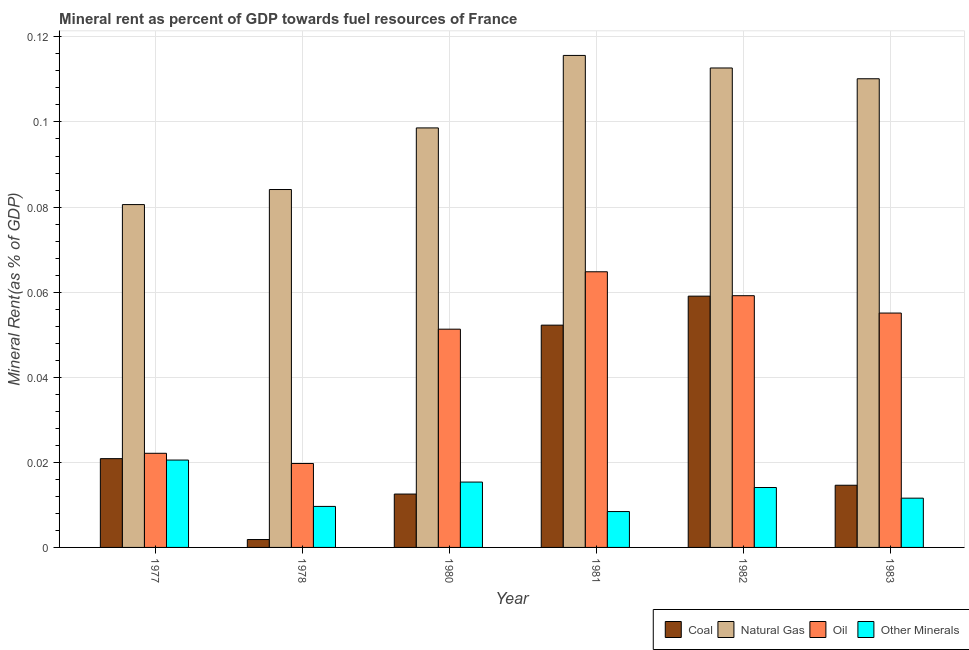How many different coloured bars are there?
Make the answer very short. 4. Are the number of bars per tick equal to the number of legend labels?
Ensure brevity in your answer.  Yes. How many bars are there on the 3rd tick from the left?
Your response must be concise. 4. How many bars are there on the 4th tick from the right?
Keep it short and to the point. 4. What is the label of the 5th group of bars from the left?
Your answer should be very brief. 1982. In how many cases, is the number of bars for a given year not equal to the number of legend labels?
Provide a short and direct response. 0. What is the coal rent in 1977?
Provide a succinct answer. 0.02. Across all years, what is the maximum natural gas rent?
Keep it short and to the point. 0.12. Across all years, what is the minimum  rent of other minerals?
Make the answer very short. 0.01. What is the total  rent of other minerals in the graph?
Provide a short and direct response. 0.08. What is the difference between the coal rent in 1977 and that in 1983?
Offer a very short reply. 0.01. What is the difference between the  rent of other minerals in 1977 and the coal rent in 1981?
Offer a very short reply. 0.01. What is the average  rent of other minerals per year?
Keep it short and to the point. 0.01. What is the ratio of the oil rent in 1982 to that in 1983?
Your response must be concise. 1.07. Is the difference between the coal rent in 1977 and 1983 greater than the difference between the oil rent in 1977 and 1983?
Ensure brevity in your answer.  No. What is the difference between the highest and the second highest  rent of other minerals?
Give a very brief answer. 0.01. What is the difference between the highest and the lowest natural gas rent?
Provide a succinct answer. 0.04. Is it the case that in every year, the sum of the oil rent and coal rent is greater than the sum of natural gas rent and  rent of other minerals?
Offer a very short reply. Yes. What does the 2nd bar from the left in 1981 represents?
Your answer should be very brief. Natural Gas. What does the 3rd bar from the right in 1977 represents?
Your answer should be compact. Natural Gas. Is it the case that in every year, the sum of the coal rent and natural gas rent is greater than the oil rent?
Provide a short and direct response. Yes. Are all the bars in the graph horizontal?
Keep it short and to the point. No. How many years are there in the graph?
Your response must be concise. 6. What is the difference between two consecutive major ticks on the Y-axis?
Give a very brief answer. 0.02. How many legend labels are there?
Provide a short and direct response. 4. How are the legend labels stacked?
Make the answer very short. Horizontal. What is the title of the graph?
Give a very brief answer. Mineral rent as percent of GDP towards fuel resources of France. What is the label or title of the Y-axis?
Make the answer very short. Mineral Rent(as % of GDP). What is the Mineral Rent(as % of GDP) of Coal in 1977?
Provide a short and direct response. 0.02. What is the Mineral Rent(as % of GDP) of Natural Gas in 1977?
Provide a short and direct response. 0.08. What is the Mineral Rent(as % of GDP) in Oil in 1977?
Provide a short and direct response. 0.02. What is the Mineral Rent(as % of GDP) in Other Minerals in 1977?
Make the answer very short. 0.02. What is the Mineral Rent(as % of GDP) of Coal in 1978?
Your response must be concise. 0. What is the Mineral Rent(as % of GDP) of Natural Gas in 1978?
Give a very brief answer. 0.08. What is the Mineral Rent(as % of GDP) in Oil in 1978?
Give a very brief answer. 0.02. What is the Mineral Rent(as % of GDP) in Other Minerals in 1978?
Offer a terse response. 0.01. What is the Mineral Rent(as % of GDP) in Coal in 1980?
Offer a very short reply. 0.01. What is the Mineral Rent(as % of GDP) of Natural Gas in 1980?
Give a very brief answer. 0.1. What is the Mineral Rent(as % of GDP) of Oil in 1980?
Your answer should be compact. 0.05. What is the Mineral Rent(as % of GDP) of Other Minerals in 1980?
Provide a succinct answer. 0.02. What is the Mineral Rent(as % of GDP) of Coal in 1981?
Give a very brief answer. 0.05. What is the Mineral Rent(as % of GDP) of Natural Gas in 1981?
Provide a short and direct response. 0.12. What is the Mineral Rent(as % of GDP) in Oil in 1981?
Offer a terse response. 0.06. What is the Mineral Rent(as % of GDP) of Other Minerals in 1981?
Provide a short and direct response. 0.01. What is the Mineral Rent(as % of GDP) of Coal in 1982?
Give a very brief answer. 0.06. What is the Mineral Rent(as % of GDP) of Natural Gas in 1982?
Keep it short and to the point. 0.11. What is the Mineral Rent(as % of GDP) in Oil in 1982?
Your answer should be very brief. 0.06. What is the Mineral Rent(as % of GDP) in Other Minerals in 1982?
Provide a succinct answer. 0.01. What is the Mineral Rent(as % of GDP) in Coal in 1983?
Your response must be concise. 0.01. What is the Mineral Rent(as % of GDP) of Natural Gas in 1983?
Keep it short and to the point. 0.11. What is the Mineral Rent(as % of GDP) of Oil in 1983?
Make the answer very short. 0.06. What is the Mineral Rent(as % of GDP) in Other Minerals in 1983?
Your answer should be compact. 0.01. Across all years, what is the maximum Mineral Rent(as % of GDP) of Coal?
Give a very brief answer. 0.06. Across all years, what is the maximum Mineral Rent(as % of GDP) in Natural Gas?
Give a very brief answer. 0.12. Across all years, what is the maximum Mineral Rent(as % of GDP) in Oil?
Make the answer very short. 0.06. Across all years, what is the maximum Mineral Rent(as % of GDP) of Other Minerals?
Your response must be concise. 0.02. Across all years, what is the minimum Mineral Rent(as % of GDP) of Coal?
Your answer should be compact. 0. Across all years, what is the minimum Mineral Rent(as % of GDP) in Natural Gas?
Ensure brevity in your answer.  0.08. Across all years, what is the minimum Mineral Rent(as % of GDP) of Oil?
Give a very brief answer. 0.02. Across all years, what is the minimum Mineral Rent(as % of GDP) in Other Minerals?
Ensure brevity in your answer.  0.01. What is the total Mineral Rent(as % of GDP) in Coal in the graph?
Provide a short and direct response. 0.16. What is the total Mineral Rent(as % of GDP) in Natural Gas in the graph?
Provide a succinct answer. 0.6. What is the total Mineral Rent(as % of GDP) of Oil in the graph?
Ensure brevity in your answer.  0.27. What is the total Mineral Rent(as % of GDP) of Other Minerals in the graph?
Make the answer very short. 0.08. What is the difference between the Mineral Rent(as % of GDP) of Coal in 1977 and that in 1978?
Your response must be concise. 0.02. What is the difference between the Mineral Rent(as % of GDP) of Natural Gas in 1977 and that in 1978?
Make the answer very short. -0. What is the difference between the Mineral Rent(as % of GDP) of Oil in 1977 and that in 1978?
Give a very brief answer. 0. What is the difference between the Mineral Rent(as % of GDP) in Other Minerals in 1977 and that in 1978?
Keep it short and to the point. 0.01. What is the difference between the Mineral Rent(as % of GDP) in Coal in 1977 and that in 1980?
Your response must be concise. 0.01. What is the difference between the Mineral Rent(as % of GDP) in Natural Gas in 1977 and that in 1980?
Provide a short and direct response. -0.02. What is the difference between the Mineral Rent(as % of GDP) of Oil in 1977 and that in 1980?
Your answer should be very brief. -0.03. What is the difference between the Mineral Rent(as % of GDP) in Other Minerals in 1977 and that in 1980?
Provide a succinct answer. 0.01. What is the difference between the Mineral Rent(as % of GDP) of Coal in 1977 and that in 1981?
Your response must be concise. -0.03. What is the difference between the Mineral Rent(as % of GDP) in Natural Gas in 1977 and that in 1981?
Your answer should be compact. -0.04. What is the difference between the Mineral Rent(as % of GDP) of Oil in 1977 and that in 1981?
Your response must be concise. -0.04. What is the difference between the Mineral Rent(as % of GDP) of Other Minerals in 1977 and that in 1981?
Give a very brief answer. 0.01. What is the difference between the Mineral Rent(as % of GDP) of Coal in 1977 and that in 1982?
Ensure brevity in your answer.  -0.04. What is the difference between the Mineral Rent(as % of GDP) of Natural Gas in 1977 and that in 1982?
Your answer should be very brief. -0.03. What is the difference between the Mineral Rent(as % of GDP) of Oil in 1977 and that in 1982?
Your answer should be very brief. -0.04. What is the difference between the Mineral Rent(as % of GDP) of Other Minerals in 1977 and that in 1982?
Your answer should be very brief. 0.01. What is the difference between the Mineral Rent(as % of GDP) of Coal in 1977 and that in 1983?
Your answer should be very brief. 0.01. What is the difference between the Mineral Rent(as % of GDP) in Natural Gas in 1977 and that in 1983?
Your response must be concise. -0.03. What is the difference between the Mineral Rent(as % of GDP) in Oil in 1977 and that in 1983?
Keep it short and to the point. -0.03. What is the difference between the Mineral Rent(as % of GDP) of Other Minerals in 1977 and that in 1983?
Your response must be concise. 0.01. What is the difference between the Mineral Rent(as % of GDP) of Coal in 1978 and that in 1980?
Provide a succinct answer. -0.01. What is the difference between the Mineral Rent(as % of GDP) in Natural Gas in 1978 and that in 1980?
Give a very brief answer. -0.01. What is the difference between the Mineral Rent(as % of GDP) in Oil in 1978 and that in 1980?
Your response must be concise. -0.03. What is the difference between the Mineral Rent(as % of GDP) in Other Minerals in 1978 and that in 1980?
Your answer should be compact. -0.01. What is the difference between the Mineral Rent(as % of GDP) of Coal in 1978 and that in 1981?
Give a very brief answer. -0.05. What is the difference between the Mineral Rent(as % of GDP) in Natural Gas in 1978 and that in 1981?
Your answer should be very brief. -0.03. What is the difference between the Mineral Rent(as % of GDP) of Oil in 1978 and that in 1981?
Give a very brief answer. -0.05. What is the difference between the Mineral Rent(as % of GDP) of Other Minerals in 1978 and that in 1981?
Give a very brief answer. 0. What is the difference between the Mineral Rent(as % of GDP) in Coal in 1978 and that in 1982?
Ensure brevity in your answer.  -0.06. What is the difference between the Mineral Rent(as % of GDP) of Natural Gas in 1978 and that in 1982?
Provide a succinct answer. -0.03. What is the difference between the Mineral Rent(as % of GDP) in Oil in 1978 and that in 1982?
Make the answer very short. -0.04. What is the difference between the Mineral Rent(as % of GDP) of Other Minerals in 1978 and that in 1982?
Your answer should be very brief. -0. What is the difference between the Mineral Rent(as % of GDP) of Coal in 1978 and that in 1983?
Your answer should be very brief. -0.01. What is the difference between the Mineral Rent(as % of GDP) in Natural Gas in 1978 and that in 1983?
Provide a short and direct response. -0.03. What is the difference between the Mineral Rent(as % of GDP) in Oil in 1978 and that in 1983?
Ensure brevity in your answer.  -0.04. What is the difference between the Mineral Rent(as % of GDP) in Other Minerals in 1978 and that in 1983?
Offer a very short reply. -0. What is the difference between the Mineral Rent(as % of GDP) in Coal in 1980 and that in 1981?
Provide a succinct answer. -0.04. What is the difference between the Mineral Rent(as % of GDP) of Natural Gas in 1980 and that in 1981?
Provide a short and direct response. -0.02. What is the difference between the Mineral Rent(as % of GDP) of Oil in 1980 and that in 1981?
Keep it short and to the point. -0.01. What is the difference between the Mineral Rent(as % of GDP) of Other Minerals in 1980 and that in 1981?
Make the answer very short. 0.01. What is the difference between the Mineral Rent(as % of GDP) of Coal in 1980 and that in 1982?
Provide a short and direct response. -0.05. What is the difference between the Mineral Rent(as % of GDP) of Natural Gas in 1980 and that in 1982?
Make the answer very short. -0.01. What is the difference between the Mineral Rent(as % of GDP) of Oil in 1980 and that in 1982?
Offer a very short reply. -0.01. What is the difference between the Mineral Rent(as % of GDP) in Other Minerals in 1980 and that in 1982?
Give a very brief answer. 0. What is the difference between the Mineral Rent(as % of GDP) in Coal in 1980 and that in 1983?
Offer a terse response. -0. What is the difference between the Mineral Rent(as % of GDP) of Natural Gas in 1980 and that in 1983?
Provide a short and direct response. -0.01. What is the difference between the Mineral Rent(as % of GDP) of Oil in 1980 and that in 1983?
Provide a short and direct response. -0. What is the difference between the Mineral Rent(as % of GDP) in Other Minerals in 1980 and that in 1983?
Ensure brevity in your answer.  0. What is the difference between the Mineral Rent(as % of GDP) in Coal in 1981 and that in 1982?
Offer a terse response. -0.01. What is the difference between the Mineral Rent(as % of GDP) in Natural Gas in 1981 and that in 1982?
Offer a very short reply. 0. What is the difference between the Mineral Rent(as % of GDP) in Oil in 1981 and that in 1982?
Provide a short and direct response. 0.01. What is the difference between the Mineral Rent(as % of GDP) in Other Minerals in 1981 and that in 1982?
Provide a short and direct response. -0.01. What is the difference between the Mineral Rent(as % of GDP) of Coal in 1981 and that in 1983?
Keep it short and to the point. 0.04. What is the difference between the Mineral Rent(as % of GDP) of Natural Gas in 1981 and that in 1983?
Keep it short and to the point. 0.01. What is the difference between the Mineral Rent(as % of GDP) in Oil in 1981 and that in 1983?
Keep it short and to the point. 0.01. What is the difference between the Mineral Rent(as % of GDP) in Other Minerals in 1981 and that in 1983?
Make the answer very short. -0. What is the difference between the Mineral Rent(as % of GDP) of Coal in 1982 and that in 1983?
Provide a succinct answer. 0.04. What is the difference between the Mineral Rent(as % of GDP) in Natural Gas in 1982 and that in 1983?
Provide a short and direct response. 0. What is the difference between the Mineral Rent(as % of GDP) in Oil in 1982 and that in 1983?
Your answer should be compact. 0. What is the difference between the Mineral Rent(as % of GDP) in Other Minerals in 1982 and that in 1983?
Give a very brief answer. 0. What is the difference between the Mineral Rent(as % of GDP) in Coal in 1977 and the Mineral Rent(as % of GDP) in Natural Gas in 1978?
Your answer should be compact. -0.06. What is the difference between the Mineral Rent(as % of GDP) of Coal in 1977 and the Mineral Rent(as % of GDP) of Oil in 1978?
Your answer should be very brief. 0. What is the difference between the Mineral Rent(as % of GDP) of Coal in 1977 and the Mineral Rent(as % of GDP) of Other Minerals in 1978?
Offer a terse response. 0.01. What is the difference between the Mineral Rent(as % of GDP) of Natural Gas in 1977 and the Mineral Rent(as % of GDP) of Oil in 1978?
Your response must be concise. 0.06. What is the difference between the Mineral Rent(as % of GDP) of Natural Gas in 1977 and the Mineral Rent(as % of GDP) of Other Minerals in 1978?
Offer a very short reply. 0.07. What is the difference between the Mineral Rent(as % of GDP) of Oil in 1977 and the Mineral Rent(as % of GDP) of Other Minerals in 1978?
Make the answer very short. 0.01. What is the difference between the Mineral Rent(as % of GDP) in Coal in 1977 and the Mineral Rent(as % of GDP) in Natural Gas in 1980?
Offer a terse response. -0.08. What is the difference between the Mineral Rent(as % of GDP) in Coal in 1977 and the Mineral Rent(as % of GDP) in Oil in 1980?
Provide a succinct answer. -0.03. What is the difference between the Mineral Rent(as % of GDP) of Coal in 1977 and the Mineral Rent(as % of GDP) of Other Minerals in 1980?
Your response must be concise. 0.01. What is the difference between the Mineral Rent(as % of GDP) in Natural Gas in 1977 and the Mineral Rent(as % of GDP) in Oil in 1980?
Provide a short and direct response. 0.03. What is the difference between the Mineral Rent(as % of GDP) in Natural Gas in 1977 and the Mineral Rent(as % of GDP) in Other Minerals in 1980?
Make the answer very short. 0.07. What is the difference between the Mineral Rent(as % of GDP) of Oil in 1977 and the Mineral Rent(as % of GDP) of Other Minerals in 1980?
Provide a succinct answer. 0.01. What is the difference between the Mineral Rent(as % of GDP) in Coal in 1977 and the Mineral Rent(as % of GDP) in Natural Gas in 1981?
Ensure brevity in your answer.  -0.09. What is the difference between the Mineral Rent(as % of GDP) of Coal in 1977 and the Mineral Rent(as % of GDP) of Oil in 1981?
Make the answer very short. -0.04. What is the difference between the Mineral Rent(as % of GDP) of Coal in 1977 and the Mineral Rent(as % of GDP) of Other Minerals in 1981?
Make the answer very short. 0.01. What is the difference between the Mineral Rent(as % of GDP) in Natural Gas in 1977 and the Mineral Rent(as % of GDP) in Oil in 1981?
Your answer should be compact. 0.02. What is the difference between the Mineral Rent(as % of GDP) in Natural Gas in 1977 and the Mineral Rent(as % of GDP) in Other Minerals in 1981?
Offer a very short reply. 0.07. What is the difference between the Mineral Rent(as % of GDP) in Oil in 1977 and the Mineral Rent(as % of GDP) in Other Minerals in 1981?
Ensure brevity in your answer.  0.01. What is the difference between the Mineral Rent(as % of GDP) of Coal in 1977 and the Mineral Rent(as % of GDP) of Natural Gas in 1982?
Your answer should be compact. -0.09. What is the difference between the Mineral Rent(as % of GDP) of Coal in 1977 and the Mineral Rent(as % of GDP) of Oil in 1982?
Give a very brief answer. -0.04. What is the difference between the Mineral Rent(as % of GDP) in Coal in 1977 and the Mineral Rent(as % of GDP) in Other Minerals in 1982?
Your response must be concise. 0.01. What is the difference between the Mineral Rent(as % of GDP) in Natural Gas in 1977 and the Mineral Rent(as % of GDP) in Oil in 1982?
Ensure brevity in your answer.  0.02. What is the difference between the Mineral Rent(as % of GDP) of Natural Gas in 1977 and the Mineral Rent(as % of GDP) of Other Minerals in 1982?
Ensure brevity in your answer.  0.07. What is the difference between the Mineral Rent(as % of GDP) in Oil in 1977 and the Mineral Rent(as % of GDP) in Other Minerals in 1982?
Your answer should be compact. 0.01. What is the difference between the Mineral Rent(as % of GDP) in Coal in 1977 and the Mineral Rent(as % of GDP) in Natural Gas in 1983?
Your answer should be compact. -0.09. What is the difference between the Mineral Rent(as % of GDP) in Coal in 1977 and the Mineral Rent(as % of GDP) in Oil in 1983?
Your response must be concise. -0.03. What is the difference between the Mineral Rent(as % of GDP) in Coal in 1977 and the Mineral Rent(as % of GDP) in Other Minerals in 1983?
Your response must be concise. 0.01. What is the difference between the Mineral Rent(as % of GDP) of Natural Gas in 1977 and the Mineral Rent(as % of GDP) of Oil in 1983?
Offer a terse response. 0.03. What is the difference between the Mineral Rent(as % of GDP) of Natural Gas in 1977 and the Mineral Rent(as % of GDP) of Other Minerals in 1983?
Provide a succinct answer. 0.07. What is the difference between the Mineral Rent(as % of GDP) in Oil in 1977 and the Mineral Rent(as % of GDP) in Other Minerals in 1983?
Your answer should be very brief. 0.01. What is the difference between the Mineral Rent(as % of GDP) of Coal in 1978 and the Mineral Rent(as % of GDP) of Natural Gas in 1980?
Provide a succinct answer. -0.1. What is the difference between the Mineral Rent(as % of GDP) of Coal in 1978 and the Mineral Rent(as % of GDP) of Oil in 1980?
Make the answer very short. -0.05. What is the difference between the Mineral Rent(as % of GDP) of Coal in 1978 and the Mineral Rent(as % of GDP) of Other Minerals in 1980?
Ensure brevity in your answer.  -0.01. What is the difference between the Mineral Rent(as % of GDP) in Natural Gas in 1978 and the Mineral Rent(as % of GDP) in Oil in 1980?
Offer a terse response. 0.03. What is the difference between the Mineral Rent(as % of GDP) of Natural Gas in 1978 and the Mineral Rent(as % of GDP) of Other Minerals in 1980?
Make the answer very short. 0.07. What is the difference between the Mineral Rent(as % of GDP) of Oil in 1978 and the Mineral Rent(as % of GDP) of Other Minerals in 1980?
Offer a very short reply. 0. What is the difference between the Mineral Rent(as % of GDP) of Coal in 1978 and the Mineral Rent(as % of GDP) of Natural Gas in 1981?
Provide a short and direct response. -0.11. What is the difference between the Mineral Rent(as % of GDP) of Coal in 1978 and the Mineral Rent(as % of GDP) of Oil in 1981?
Keep it short and to the point. -0.06. What is the difference between the Mineral Rent(as % of GDP) in Coal in 1978 and the Mineral Rent(as % of GDP) in Other Minerals in 1981?
Provide a succinct answer. -0.01. What is the difference between the Mineral Rent(as % of GDP) in Natural Gas in 1978 and the Mineral Rent(as % of GDP) in Oil in 1981?
Your answer should be very brief. 0.02. What is the difference between the Mineral Rent(as % of GDP) in Natural Gas in 1978 and the Mineral Rent(as % of GDP) in Other Minerals in 1981?
Provide a succinct answer. 0.08. What is the difference between the Mineral Rent(as % of GDP) of Oil in 1978 and the Mineral Rent(as % of GDP) of Other Minerals in 1981?
Keep it short and to the point. 0.01. What is the difference between the Mineral Rent(as % of GDP) in Coal in 1978 and the Mineral Rent(as % of GDP) in Natural Gas in 1982?
Make the answer very short. -0.11. What is the difference between the Mineral Rent(as % of GDP) of Coal in 1978 and the Mineral Rent(as % of GDP) of Oil in 1982?
Your answer should be compact. -0.06. What is the difference between the Mineral Rent(as % of GDP) of Coal in 1978 and the Mineral Rent(as % of GDP) of Other Minerals in 1982?
Make the answer very short. -0.01. What is the difference between the Mineral Rent(as % of GDP) of Natural Gas in 1978 and the Mineral Rent(as % of GDP) of Oil in 1982?
Offer a very short reply. 0.03. What is the difference between the Mineral Rent(as % of GDP) of Natural Gas in 1978 and the Mineral Rent(as % of GDP) of Other Minerals in 1982?
Your answer should be compact. 0.07. What is the difference between the Mineral Rent(as % of GDP) in Oil in 1978 and the Mineral Rent(as % of GDP) in Other Minerals in 1982?
Your response must be concise. 0.01. What is the difference between the Mineral Rent(as % of GDP) in Coal in 1978 and the Mineral Rent(as % of GDP) in Natural Gas in 1983?
Provide a short and direct response. -0.11. What is the difference between the Mineral Rent(as % of GDP) of Coal in 1978 and the Mineral Rent(as % of GDP) of Oil in 1983?
Provide a short and direct response. -0.05. What is the difference between the Mineral Rent(as % of GDP) in Coal in 1978 and the Mineral Rent(as % of GDP) in Other Minerals in 1983?
Offer a very short reply. -0.01. What is the difference between the Mineral Rent(as % of GDP) in Natural Gas in 1978 and the Mineral Rent(as % of GDP) in Oil in 1983?
Provide a short and direct response. 0.03. What is the difference between the Mineral Rent(as % of GDP) in Natural Gas in 1978 and the Mineral Rent(as % of GDP) in Other Minerals in 1983?
Offer a very short reply. 0.07. What is the difference between the Mineral Rent(as % of GDP) of Oil in 1978 and the Mineral Rent(as % of GDP) of Other Minerals in 1983?
Your answer should be compact. 0.01. What is the difference between the Mineral Rent(as % of GDP) of Coal in 1980 and the Mineral Rent(as % of GDP) of Natural Gas in 1981?
Keep it short and to the point. -0.1. What is the difference between the Mineral Rent(as % of GDP) of Coal in 1980 and the Mineral Rent(as % of GDP) of Oil in 1981?
Offer a very short reply. -0.05. What is the difference between the Mineral Rent(as % of GDP) of Coal in 1980 and the Mineral Rent(as % of GDP) of Other Minerals in 1981?
Give a very brief answer. 0. What is the difference between the Mineral Rent(as % of GDP) of Natural Gas in 1980 and the Mineral Rent(as % of GDP) of Oil in 1981?
Your answer should be very brief. 0.03. What is the difference between the Mineral Rent(as % of GDP) in Natural Gas in 1980 and the Mineral Rent(as % of GDP) in Other Minerals in 1981?
Offer a terse response. 0.09. What is the difference between the Mineral Rent(as % of GDP) in Oil in 1980 and the Mineral Rent(as % of GDP) in Other Minerals in 1981?
Provide a short and direct response. 0.04. What is the difference between the Mineral Rent(as % of GDP) in Coal in 1980 and the Mineral Rent(as % of GDP) in Natural Gas in 1982?
Your answer should be very brief. -0.1. What is the difference between the Mineral Rent(as % of GDP) of Coal in 1980 and the Mineral Rent(as % of GDP) of Oil in 1982?
Provide a succinct answer. -0.05. What is the difference between the Mineral Rent(as % of GDP) in Coal in 1980 and the Mineral Rent(as % of GDP) in Other Minerals in 1982?
Your response must be concise. -0. What is the difference between the Mineral Rent(as % of GDP) in Natural Gas in 1980 and the Mineral Rent(as % of GDP) in Oil in 1982?
Make the answer very short. 0.04. What is the difference between the Mineral Rent(as % of GDP) of Natural Gas in 1980 and the Mineral Rent(as % of GDP) of Other Minerals in 1982?
Your answer should be compact. 0.08. What is the difference between the Mineral Rent(as % of GDP) of Oil in 1980 and the Mineral Rent(as % of GDP) of Other Minerals in 1982?
Your answer should be compact. 0.04. What is the difference between the Mineral Rent(as % of GDP) in Coal in 1980 and the Mineral Rent(as % of GDP) in Natural Gas in 1983?
Your answer should be very brief. -0.1. What is the difference between the Mineral Rent(as % of GDP) of Coal in 1980 and the Mineral Rent(as % of GDP) of Oil in 1983?
Keep it short and to the point. -0.04. What is the difference between the Mineral Rent(as % of GDP) in Natural Gas in 1980 and the Mineral Rent(as % of GDP) in Oil in 1983?
Your answer should be compact. 0.04. What is the difference between the Mineral Rent(as % of GDP) in Natural Gas in 1980 and the Mineral Rent(as % of GDP) in Other Minerals in 1983?
Keep it short and to the point. 0.09. What is the difference between the Mineral Rent(as % of GDP) of Oil in 1980 and the Mineral Rent(as % of GDP) of Other Minerals in 1983?
Your answer should be compact. 0.04. What is the difference between the Mineral Rent(as % of GDP) of Coal in 1981 and the Mineral Rent(as % of GDP) of Natural Gas in 1982?
Your answer should be very brief. -0.06. What is the difference between the Mineral Rent(as % of GDP) in Coal in 1981 and the Mineral Rent(as % of GDP) in Oil in 1982?
Keep it short and to the point. -0.01. What is the difference between the Mineral Rent(as % of GDP) of Coal in 1981 and the Mineral Rent(as % of GDP) of Other Minerals in 1982?
Ensure brevity in your answer.  0.04. What is the difference between the Mineral Rent(as % of GDP) in Natural Gas in 1981 and the Mineral Rent(as % of GDP) in Oil in 1982?
Offer a terse response. 0.06. What is the difference between the Mineral Rent(as % of GDP) of Natural Gas in 1981 and the Mineral Rent(as % of GDP) of Other Minerals in 1982?
Keep it short and to the point. 0.1. What is the difference between the Mineral Rent(as % of GDP) of Oil in 1981 and the Mineral Rent(as % of GDP) of Other Minerals in 1982?
Make the answer very short. 0.05. What is the difference between the Mineral Rent(as % of GDP) of Coal in 1981 and the Mineral Rent(as % of GDP) of Natural Gas in 1983?
Make the answer very short. -0.06. What is the difference between the Mineral Rent(as % of GDP) of Coal in 1981 and the Mineral Rent(as % of GDP) of Oil in 1983?
Offer a terse response. -0. What is the difference between the Mineral Rent(as % of GDP) in Coal in 1981 and the Mineral Rent(as % of GDP) in Other Minerals in 1983?
Make the answer very short. 0.04. What is the difference between the Mineral Rent(as % of GDP) in Natural Gas in 1981 and the Mineral Rent(as % of GDP) in Oil in 1983?
Give a very brief answer. 0.06. What is the difference between the Mineral Rent(as % of GDP) in Natural Gas in 1981 and the Mineral Rent(as % of GDP) in Other Minerals in 1983?
Give a very brief answer. 0.1. What is the difference between the Mineral Rent(as % of GDP) of Oil in 1981 and the Mineral Rent(as % of GDP) of Other Minerals in 1983?
Provide a short and direct response. 0.05. What is the difference between the Mineral Rent(as % of GDP) of Coal in 1982 and the Mineral Rent(as % of GDP) of Natural Gas in 1983?
Offer a terse response. -0.05. What is the difference between the Mineral Rent(as % of GDP) of Coal in 1982 and the Mineral Rent(as % of GDP) of Oil in 1983?
Ensure brevity in your answer.  0. What is the difference between the Mineral Rent(as % of GDP) of Coal in 1982 and the Mineral Rent(as % of GDP) of Other Minerals in 1983?
Your response must be concise. 0.05. What is the difference between the Mineral Rent(as % of GDP) in Natural Gas in 1982 and the Mineral Rent(as % of GDP) in Oil in 1983?
Offer a terse response. 0.06. What is the difference between the Mineral Rent(as % of GDP) of Natural Gas in 1982 and the Mineral Rent(as % of GDP) of Other Minerals in 1983?
Offer a very short reply. 0.1. What is the difference between the Mineral Rent(as % of GDP) of Oil in 1982 and the Mineral Rent(as % of GDP) of Other Minerals in 1983?
Provide a succinct answer. 0.05. What is the average Mineral Rent(as % of GDP) in Coal per year?
Your answer should be compact. 0.03. What is the average Mineral Rent(as % of GDP) of Natural Gas per year?
Ensure brevity in your answer.  0.1. What is the average Mineral Rent(as % of GDP) of Oil per year?
Offer a very short reply. 0.05. What is the average Mineral Rent(as % of GDP) in Other Minerals per year?
Your response must be concise. 0.01. In the year 1977, what is the difference between the Mineral Rent(as % of GDP) of Coal and Mineral Rent(as % of GDP) of Natural Gas?
Give a very brief answer. -0.06. In the year 1977, what is the difference between the Mineral Rent(as % of GDP) in Coal and Mineral Rent(as % of GDP) in Oil?
Your response must be concise. -0. In the year 1977, what is the difference between the Mineral Rent(as % of GDP) in Coal and Mineral Rent(as % of GDP) in Other Minerals?
Offer a very short reply. 0. In the year 1977, what is the difference between the Mineral Rent(as % of GDP) in Natural Gas and Mineral Rent(as % of GDP) in Oil?
Provide a short and direct response. 0.06. In the year 1977, what is the difference between the Mineral Rent(as % of GDP) in Oil and Mineral Rent(as % of GDP) in Other Minerals?
Provide a short and direct response. 0. In the year 1978, what is the difference between the Mineral Rent(as % of GDP) in Coal and Mineral Rent(as % of GDP) in Natural Gas?
Keep it short and to the point. -0.08. In the year 1978, what is the difference between the Mineral Rent(as % of GDP) in Coal and Mineral Rent(as % of GDP) in Oil?
Ensure brevity in your answer.  -0.02. In the year 1978, what is the difference between the Mineral Rent(as % of GDP) of Coal and Mineral Rent(as % of GDP) of Other Minerals?
Offer a very short reply. -0.01. In the year 1978, what is the difference between the Mineral Rent(as % of GDP) of Natural Gas and Mineral Rent(as % of GDP) of Oil?
Provide a succinct answer. 0.06. In the year 1978, what is the difference between the Mineral Rent(as % of GDP) in Natural Gas and Mineral Rent(as % of GDP) in Other Minerals?
Offer a very short reply. 0.07. In the year 1978, what is the difference between the Mineral Rent(as % of GDP) of Oil and Mineral Rent(as % of GDP) of Other Minerals?
Your answer should be compact. 0.01. In the year 1980, what is the difference between the Mineral Rent(as % of GDP) in Coal and Mineral Rent(as % of GDP) in Natural Gas?
Your answer should be compact. -0.09. In the year 1980, what is the difference between the Mineral Rent(as % of GDP) of Coal and Mineral Rent(as % of GDP) of Oil?
Your response must be concise. -0.04. In the year 1980, what is the difference between the Mineral Rent(as % of GDP) in Coal and Mineral Rent(as % of GDP) in Other Minerals?
Your response must be concise. -0. In the year 1980, what is the difference between the Mineral Rent(as % of GDP) in Natural Gas and Mineral Rent(as % of GDP) in Oil?
Ensure brevity in your answer.  0.05. In the year 1980, what is the difference between the Mineral Rent(as % of GDP) in Natural Gas and Mineral Rent(as % of GDP) in Other Minerals?
Keep it short and to the point. 0.08. In the year 1980, what is the difference between the Mineral Rent(as % of GDP) in Oil and Mineral Rent(as % of GDP) in Other Minerals?
Your answer should be compact. 0.04. In the year 1981, what is the difference between the Mineral Rent(as % of GDP) in Coal and Mineral Rent(as % of GDP) in Natural Gas?
Your answer should be very brief. -0.06. In the year 1981, what is the difference between the Mineral Rent(as % of GDP) of Coal and Mineral Rent(as % of GDP) of Oil?
Offer a terse response. -0.01. In the year 1981, what is the difference between the Mineral Rent(as % of GDP) in Coal and Mineral Rent(as % of GDP) in Other Minerals?
Make the answer very short. 0.04. In the year 1981, what is the difference between the Mineral Rent(as % of GDP) of Natural Gas and Mineral Rent(as % of GDP) of Oil?
Provide a short and direct response. 0.05. In the year 1981, what is the difference between the Mineral Rent(as % of GDP) in Natural Gas and Mineral Rent(as % of GDP) in Other Minerals?
Your answer should be very brief. 0.11. In the year 1981, what is the difference between the Mineral Rent(as % of GDP) in Oil and Mineral Rent(as % of GDP) in Other Minerals?
Your answer should be compact. 0.06. In the year 1982, what is the difference between the Mineral Rent(as % of GDP) in Coal and Mineral Rent(as % of GDP) in Natural Gas?
Ensure brevity in your answer.  -0.05. In the year 1982, what is the difference between the Mineral Rent(as % of GDP) of Coal and Mineral Rent(as % of GDP) of Oil?
Provide a succinct answer. -0. In the year 1982, what is the difference between the Mineral Rent(as % of GDP) of Coal and Mineral Rent(as % of GDP) of Other Minerals?
Provide a succinct answer. 0.04. In the year 1982, what is the difference between the Mineral Rent(as % of GDP) of Natural Gas and Mineral Rent(as % of GDP) of Oil?
Your answer should be compact. 0.05. In the year 1982, what is the difference between the Mineral Rent(as % of GDP) of Natural Gas and Mineral Rent(as % of GDP) of Other Minerals?
Ensure brevity in your answer.  0.1. In the year 1982, what is the difference between the Mineral Rent(as % of GDP) in Oil and Mineral Rent(as % of GDP) in Other Minerals?
Offer a very short reply. 0.05. In the year 1983, what is the difference between the Mineral Rent(as % of GDP) in Coal and Mineral Rent(as % of GDP) in Natural Gas?
Offer a terse response. -0.1. In the year 1983, what is the difference between the Mineral Rent(as % of GDP) in Coal and Mineral Rent(as % of GDP) in Oil?
Your answer should be very brief. -0.04. In the year 1983, what is the difference between the Mineral Rent(as % of GDP) of Coal and Mineral Rent(as % of GDP) of Other Minerals?
Provide a succinct answer. 0. In the year 1983, what is the difference between the Mineral Rent(as % of GDP) of Natural Gas and Mineral Rent(as % of GDP) of Oil?
Give a very brief answer. 0.06. In the year 1983, what is the difference between the Mineral Rent(as % of GDP) in Natural Gas and Mineral Rent(as % of GDP) in Other Minerals?
Make the answer very short. 0.1. In the year 1983, what is the difference between the Mineral Rent(as % of GDP) in Oil and Mineral Rent(as % of GDP) in Other Minerals?
Provide a succinct answer. 0.04. What is the ratio of the Mineral Rent(as % of GDP) in Coal in 1977 to that in 1978?
Provide a short and direct response. 11.27. What is the ratio of the Mineral Rent(as % of GDP) in Natural Gas in 1977 to that in 1978?
Provide a short and direct response. 0.96. What is the ratio of the Mineral Rent(as % of GDP) in Oil in 1977 to that in 1978?
Provide a short and direct response. 1.12. What is the ratio of the Mineral Rent(as % of GDP) in Other Minerals in 1977 to that in 1978?
Offer a terse response. 2.13. What is the ratio of the Mineral Rent(as % of GDP) of Coal in 1977 to that in 1980?
Offer a very short reply. 1.66. What is the ratio of the Mineral Rent(as % of GDP) in Natural Gas in 1977 to that in 1980?
Offer a terse response. 0.82. What is the ratio of the Mineral Rent(as % of GDP) in Oil in 1977 to that in 1980?
Your answer should be compact. 0.43. What is the ratio of the Mineral Rent(as % of GDP) of Other Minerals in 1977 to that in 1980?
Make the answer very short. 1.34. What is the ratio of the Mineral Rent(as % of GDP) of Coal in 1977 to that in 1981?
Your answer should be very brief. 0.4. What is the ratio of the Mineral Rent(as % of GDP) in Natural Gas in 1977 to that in 1981?
Ensure brevity in your answer.  0.7. What is the ratio of the Mineral Rent(as % of GDP) in Oil in 1977 to that in 1981?
Offer a terse response. 0.34. What is the ratio of the Mineral Rent(as % of GDP) of Other Minerals in 1977 to that in 1981?
Keep it short and to the point. 2.44. What is the ratio of the Mineral Rent(as % of GDP) in Coal in 1977 to that in 1982?
Ensure brevity in your answer.  0.35. What is the ratio of the Mineral Rent(as % of GDP) in Natural Gas in 1977 to that in 1982?
Ensure brevity in your answer.  0.72. What is the ratio of the Mineral Rent(as % of GDP) of Oil in 1977 to that in 1982?
Offer a terse response. 0.37. What is the ratio of the Mineral Rent(as % of GDP) of Other Minerals in 1977 to that in 1982?
Provide a short and direct response. 1.46. What is the ratio of the Mineral Rent(as % of GDP) in Coal in 1977 to that in 1983?
Offer a terse response. 1.43. What is the ratio of the Mineral Rent(as % of GDP) in Natural Gas in 1977 to that in 1983?
Ensure brevity in your answer.  0.73. What is the ratio of the Mineral Rent(as % of GDP) in Oil in 1977 to that in 1983?
Give a very brief answer. 0.4. What is the ratio of the Mineral Rent(as % of GDP) in Other Minerals in 1977 to that in 1983?
Provide a succinct answer. 1.77. What is the ratio of the Mineral Rent(as % of GDP) in Coal in 1978 to that in 1980?
Ensure brevity in your answer.  0.15. What is the ratio of the Mineral Rent(as % of GDP) of Natural Gas in 1978 to that in 1980?
Your answer should be compact. 0.85. What is the ratio of the Mineral Rent(as % of GDP) of Oil in 1978 to that in 1980?
Ensure brevity in your answer.  0.38. What is the ratio of the Mineral Rent(as % of GDP) of Other Minerals in 1978 to that in 1980?
Your response must be concise. 0.63. What is the ratio of the Mineral Rent(as % of GDP) in Coal in 1978 to that in 1981?
Your answer should be compact. 0.04. What is the ratio of the Mineral Rent(as % of GDP) in Natural Gas in 1978 to that in 1981?
Provide a short and direct response. 0.73. What is the ratio of the Mineral Rent(as % of GDP) in Oil in 1978 to that in 1981?
Offer a terse response. 0.3. What is the ratio of the Mineral Rent(as % of GDP) of Other Minerals in 1978 to that in 1981?
Give a very brief answer. 1.14. What is the ratio of the Mineral Rent(as % of GDP) of Coal in 1978 to that in 1982?
Your response must be concise. 0.03. What is the ratio of the Mineral Rent(as % of GDP) in Natural Gas in 1978 to that in 1982?
Provide a short and direct response. 0.75. What is the ratio of the Mineral Rent(as % of GDP) of Oil in 1978 to that in 1982?
Your answer should be very brief. 0.33. What is the ratio of the Mineral Rent(as % of GDP) of Other Minerals in 1978 to that in 1982?
Offer a very short reply. 0.68. What is the ratio of the Mineral Rent(as % of GDP) of Coal in 1978 to that in 1983?
Offer a terse response. 0.13. What is the ratio of the Mineral Rent(as % of GDP) in Natural Gas in 1978 to that in 1983?
Ensure brevity in your answer.  0.76. What is the ratio of the Mineral Rent(as % of GDP) of Oil in 1978 to that in 1983?
Offer a terse response. 0.36. What is the ratio of the Mineral Rent(as % of GDP) of Other Minerals in 1978 to that in 1983?
Provide a succinct answer. 0.83. What is the ratio of the Mineral Rent(as % of GDP) of Coal in 1980 to that in 1981?
Your answer should be compact. 0.24. What is the ratio of the Mineral Rent(as % of GDP) of Natural Gas in 1980 to that in 1981?
Make the answer very short. 0.85. What is the ratio of the Mineral Rent(as % of GDP) in Oil in 1980 to that in 1981?
Your response must be concise. 0.79. What is the ratio of the Mineral Rent(as % of GDP) of Other Minerals in 1980 to that in 1981?
Ensure brevity in your answer.  1.82. What is the ratio of the Mineral Rent(as % of GDP) in Coal in 1980 to that in 1982?
Your response must be concise. 0.21. What is the ratio of the Mineral Rent(as % of GDP) in Oil in 1980 to that in 1982?
Your response must be concise. 0.87. What is the ratio of the Mineral Rent(as % of GDP) of Other Minerals in 1980 to that in 1982?
Keep it short and to the point. 1.09. What is the ratio of the Mineral Rent(as % of GDP) of Coal in 1980 to that in 1983?
Provide a short and direct response. 0.86. What is the ratio of the Mineral Rent(as % of GDP) of Natural Gas in 1980 to that in 1983?
Your answer should be compact. 0.9. What is the ratio of the Mineral Rent(as % of GDP) of Oil in 1980 to that in 1983?
Your response must be concise. 0.93. What is the ratio of the Mineral Rent(as % of GDP) in Other Minerals in 1980 to that in 1983?
Your response must be concise. 1.33. What is the ratio of the Mineral Rent(as % of GDP) of Coal in 1981 to that in 1982?
Ensure brevity in your answer.  0.88. What is the ratio of the Mineral Rent(as % of GDP) of Natural Gas in 1981 to that in 1982?
Offer a terse response. 1.03. What is the ratio of the Mineral Rent(as % of GDP) of Oil in 1981 to that in 1982?
Offer a terse response. 1.09. What is the ratio of the Mineral Rent(as % of GDP) of Other Minerals in 1981 to that in 1982?
Keep it short and to the point. 0.6. What is the ratio of the Mineral Rent(as % of GDP) of Coal in 1981 to that in 1983?
Ensure brevity in your answer.  3.57. What is the ratio of the Mineral Rent(as % of GDP) in Natural Gas in 1981 to that in 1983?
Give a very brief answer. 1.05. What is the ratio of the Mineral Rent(as % of GDP) in Oil in 1981 to that in 1983?
Provide a succinct answer. 1.18. What is the ratio of the Mineral Rent(as % of GDP) in Other Minerals in 1981 to that in 1983?
Offer a terse response. 0.73. What is the ratio of the Mineral Rent(as % of GDP) in Coal in 1982 to that in 1983?
Ensure brevity in your answer.  4.04. What is the ratio of the Mineral Rent(as % of GDP) of Oil in 1982 to that in 1983?
Provide a succinct answer. 1.07. What is the ratio of the Mineral Rent(as % of GDP) of Other Minerals in 1982 to that in 1983?
Your answer should be very brief. 1.22. What is the difference between the highest and the second highest Mineral Rent(as % of GDP) of Coal?
Provide a short and direct response. 0.01. What is the difference between the highest and the second highest Mineral Rent(as % of GDP) of Natural Gas?
Keep it short and to the point. 0. What is the difference between the highest and the second highest Mineral Rent(as % of GDP) in Oil?
Your response must be concise. 0.01. What is the difference between the highest and the second highest Mineral Rent(as % of GDP) in Other Minerals?
Provide a short and direct response. 0.01. What is the difference between the highest and the lowest Mineral Rent(as % of GDP) of Coal?
Provide a succinct answer. 0.06. What is the difference between the highest and the lowest Mineral Rent(as % of GDP) in Natural Gas?
Offer a very short reply. 0.04. What is the difference between the highest and the lowest Mineral Rent(as % of GDP) of Oil?
Your response must be concise. 0.05. What is the difference between the highest and the lowest Mineral Rent(as % of GDP) in Other Minerals?
Your response must be concise. 0.01. 